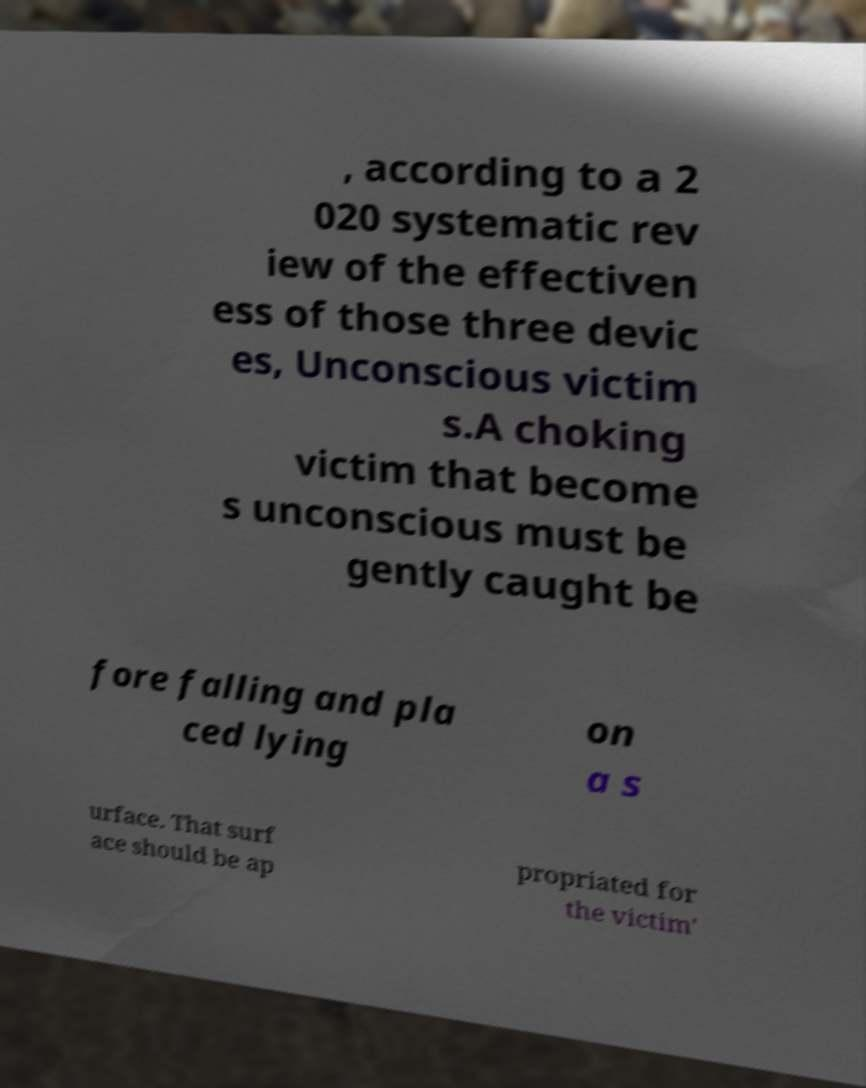For documentation purposes, I need the text within this image transcribed. Could you provide that? , according to a 2 020 systematic rev iew of the effectiven ess of those three devic es, Unconscious victim s.A choking victim that become s unconscious must be gently caught be fore falling and pla ced lying on a s urface. That surf ace should be ap propriated for the victim' 